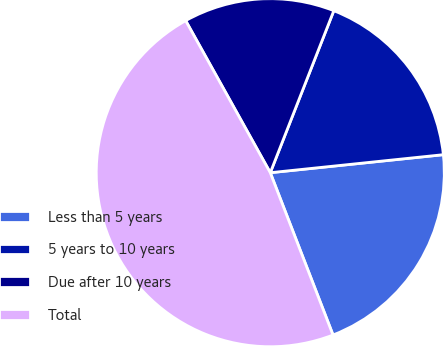Convert chart. <chart><loc_0><loc_0><loc_500><loc_500><pie_chart><fcel>Less than 5 years<fcel>5 years to 10 years<fcel>Due after 10 years<fcel>Total<nl><fcel>20.78%<fcel>17.4%<fcel>14.03%<fcel>47.79%<nl></chart> 